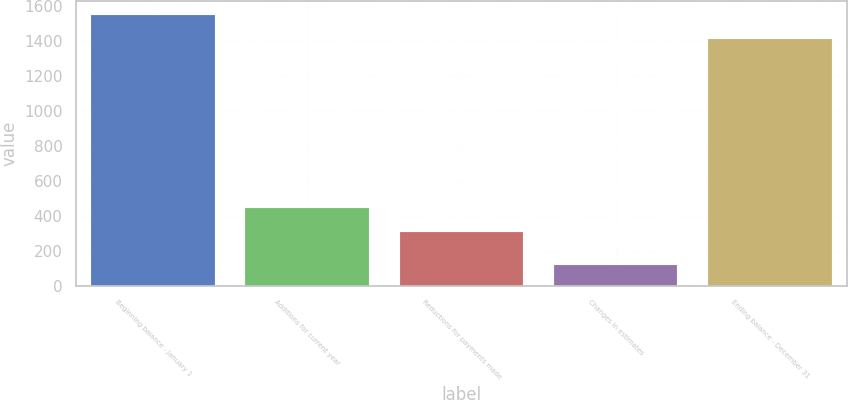<chart> <loc_0><loc_0><loc_500><loc_500><bar_chart><fcel>Beginning balance - January 1<fcel>Additions for current year<fcel>Reductions for payments made<fcel>Changes in estimates<fcel>Ending balance - December 31<nl><fcel>1550.7<fcel>445.7<fcel>309<fcel>118<fcel>1414<nl></chart> 